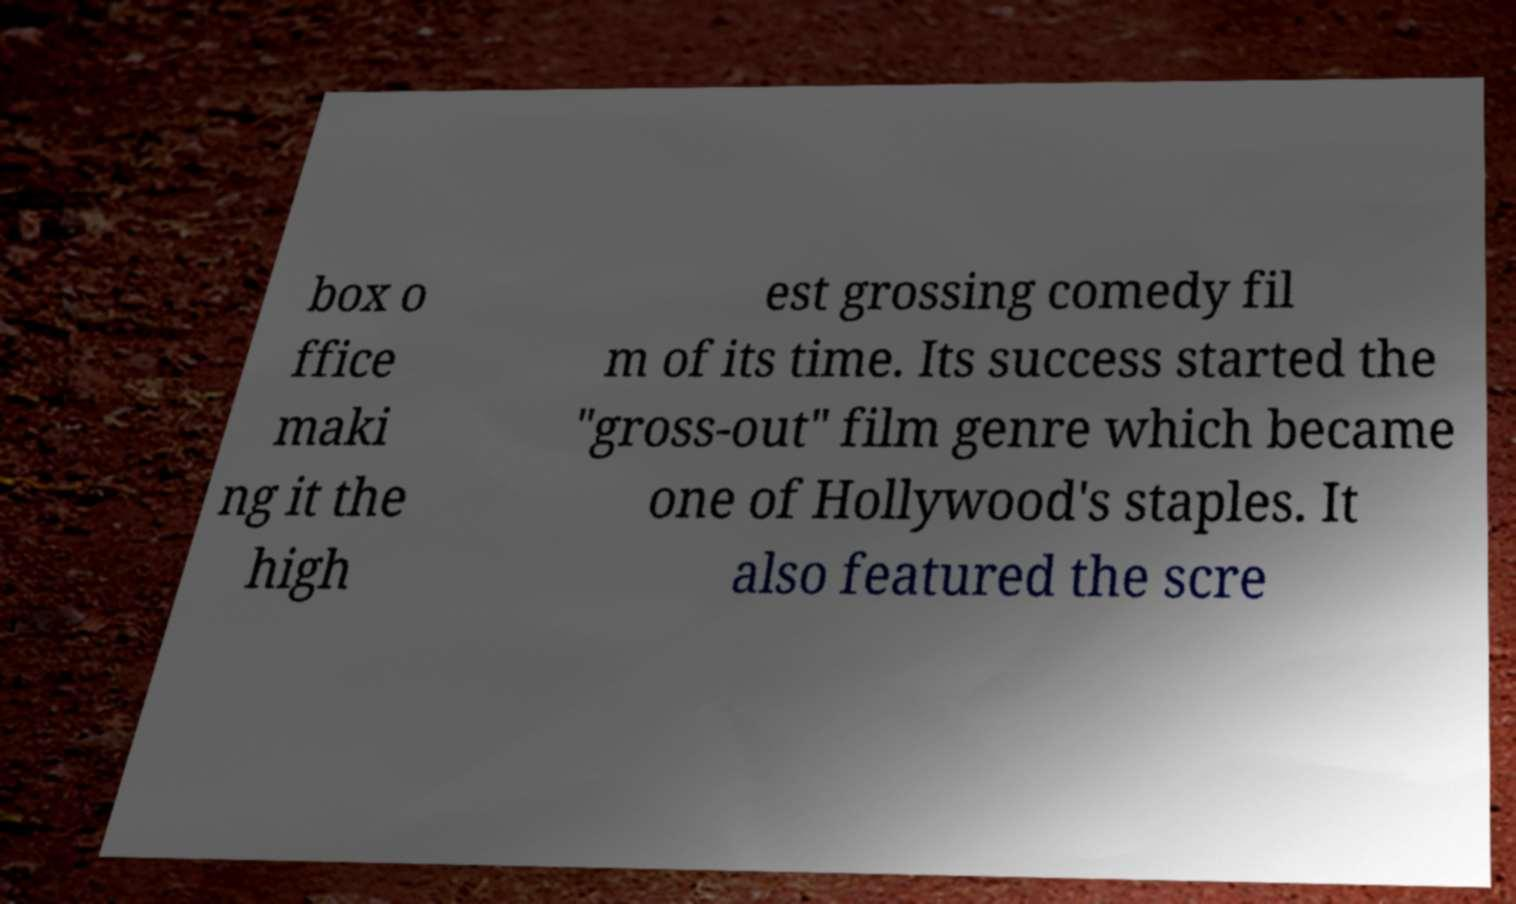Could you extract and type out the text from this image? box o ffice maki ng it the high est grossing comedy fil m of its time. Its success started the "gross-out" film genre which became one of Hollywood's staples. It also featured the scre 